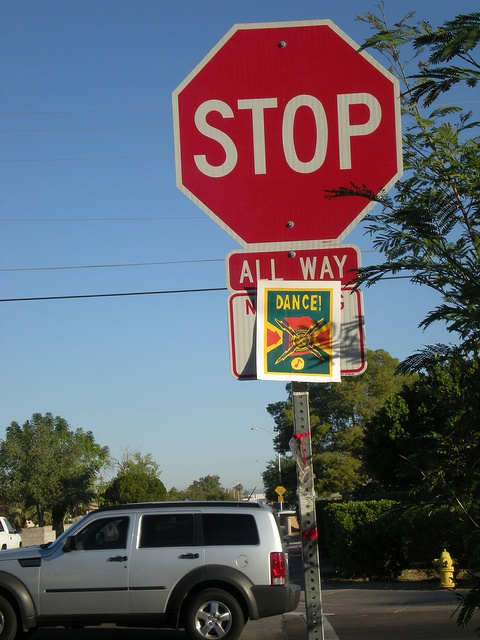Describe the objects in this image and their specific colors. I can see stop sign in gray, brown, and darkgray tones, car in gray, black, and darkgray tones, car in gray, beige, and black tones, and fire hydrant in gray, black, olive, and gold tones in this image. 